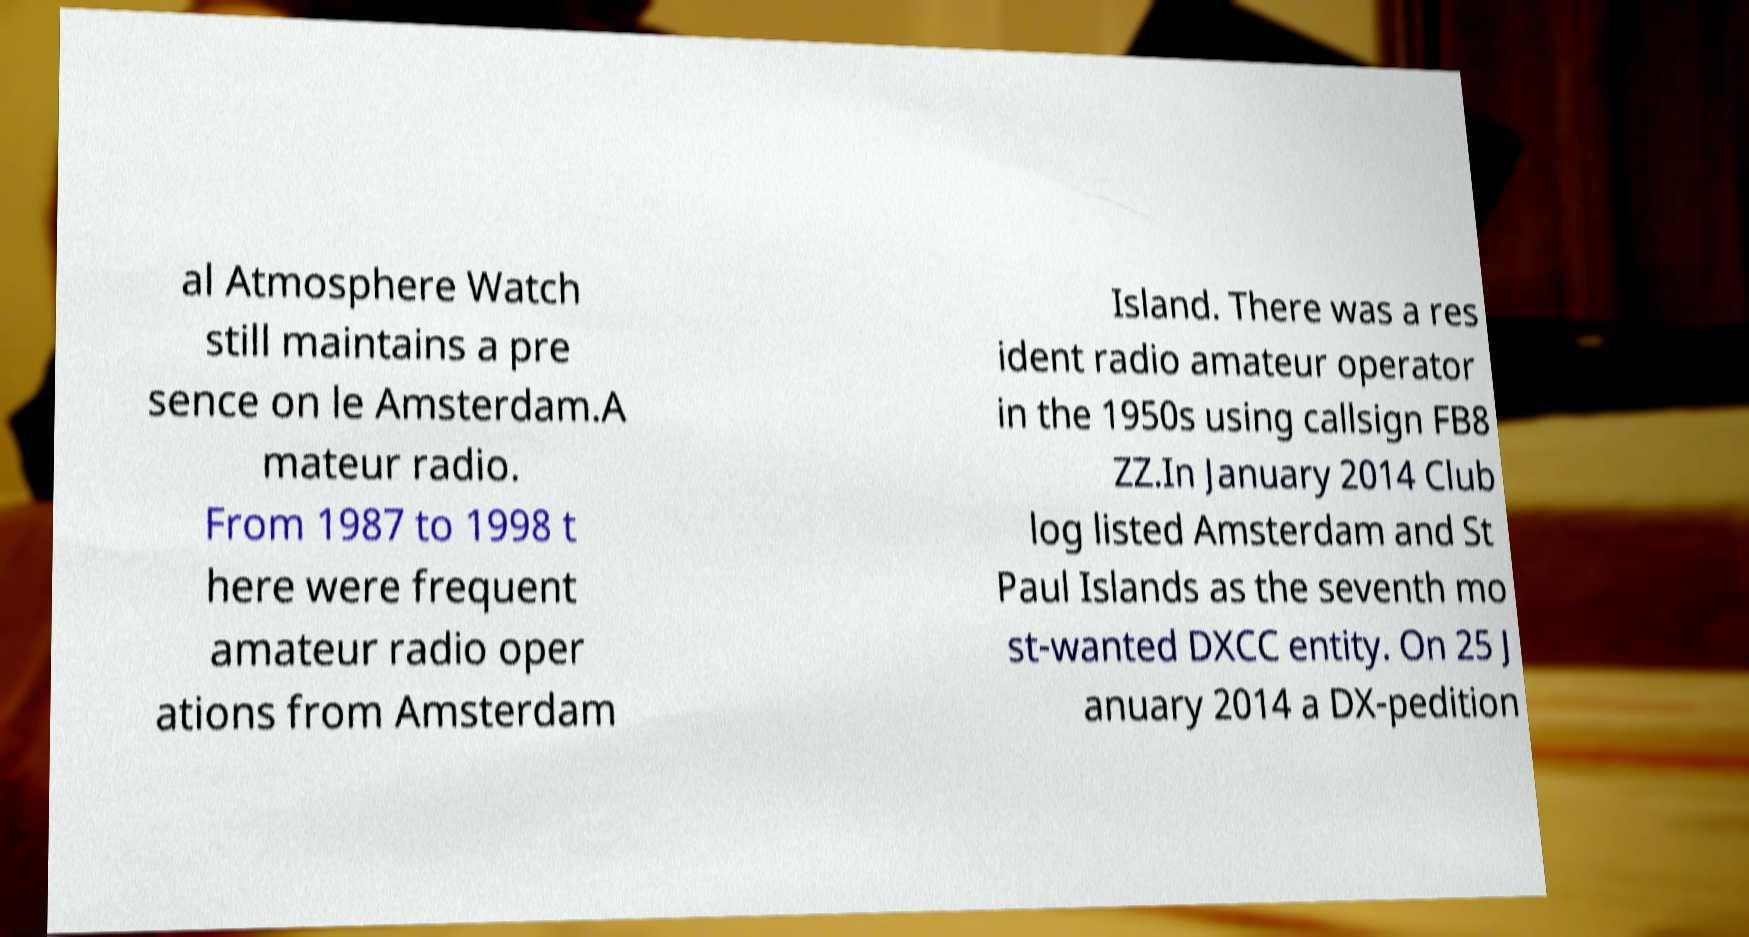There's text embedded in this image that I need extracted. Can you transcribe it verbatim? al Atmosphere Watch still maintains a pre sence on le Amsterdam.A mateur radio. From 1987 to 1998 t here were frequent amateur radio oper ations from Amsterdam Island. There was a res ident radio amateur operator in the 1950s using callsign FB8 ZZ.In January 2014 Club log listed Amsterdam and St Paul Islands as the seventh mo st-wanted DXCC entity. On 25 J anuary 2014 a DX-pedition 